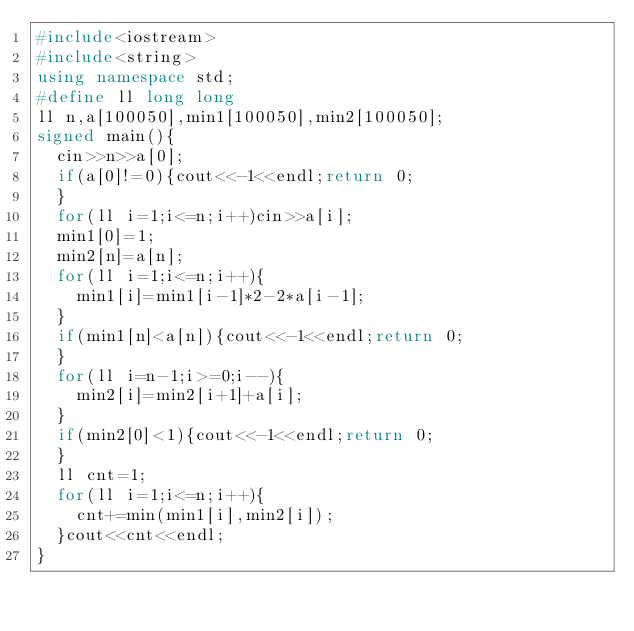Convert code to text. <code><loc_0><loc_0><loc_500><loc_500><_C++_>#include<iostream>
#include<string>
using namespace std;
#define ll long long
ll n,a[100050],min1[100050],min2[100050];
signed main(){
	cin>>n>>a[0];
	if(a[0]!=0){cout<<-1<<endl;return 0;
	}
	for(ll i=1;i<=n;i++)cin>>a[i];
	min1[0]=1;
	min2[n]=a[n];
	for(ll i=1;i<=n;i++){
		min1[i]=min1[i-1]*2-2*a[i-1];
	}
	if(min1[n]<a[n]){cout<<-1<<endl;return 0;
	}
	for(ll i=n-1;i>=0;i--){
		min2[i]=min2[i+1]+a[i];
	}
	if(min2[0]<1){cout<<-1<<endl;return 0;
	}
	ll cnt=1;
	for(ll i=1;i<=n;i++){
		cnt+=min(min1[i],min2[i]);
	}cout<<cnt<<endl;
}</code> 